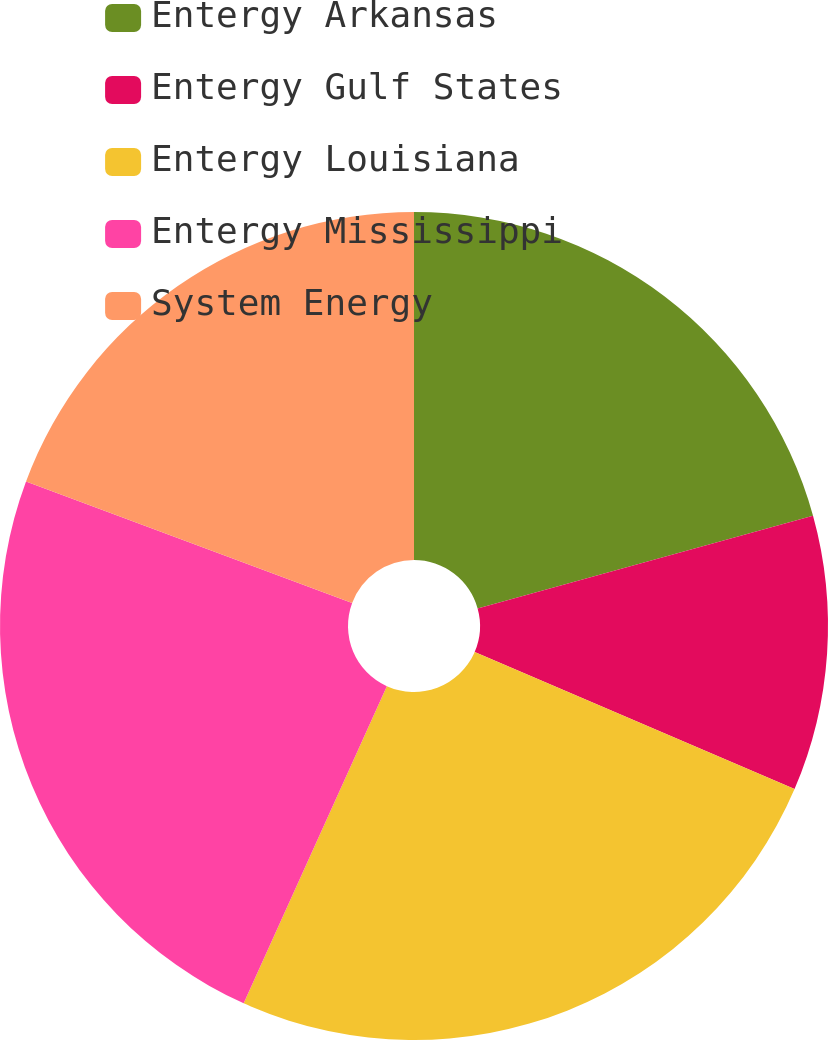<chart> <loc_0><loc_0><loc_500><loc_500><pie_chart><fcel>Entergy Arkansas<fcel>Entergy Gulf States<fcel>Entergy Louisiana<fcel>Entergy Mississippi<fcel>System Energy<nl><fcel>20.71%<fcel>10.74%<fcel>25.31%<fcel>23.93%<fcel>19.33%<nl></chart> 